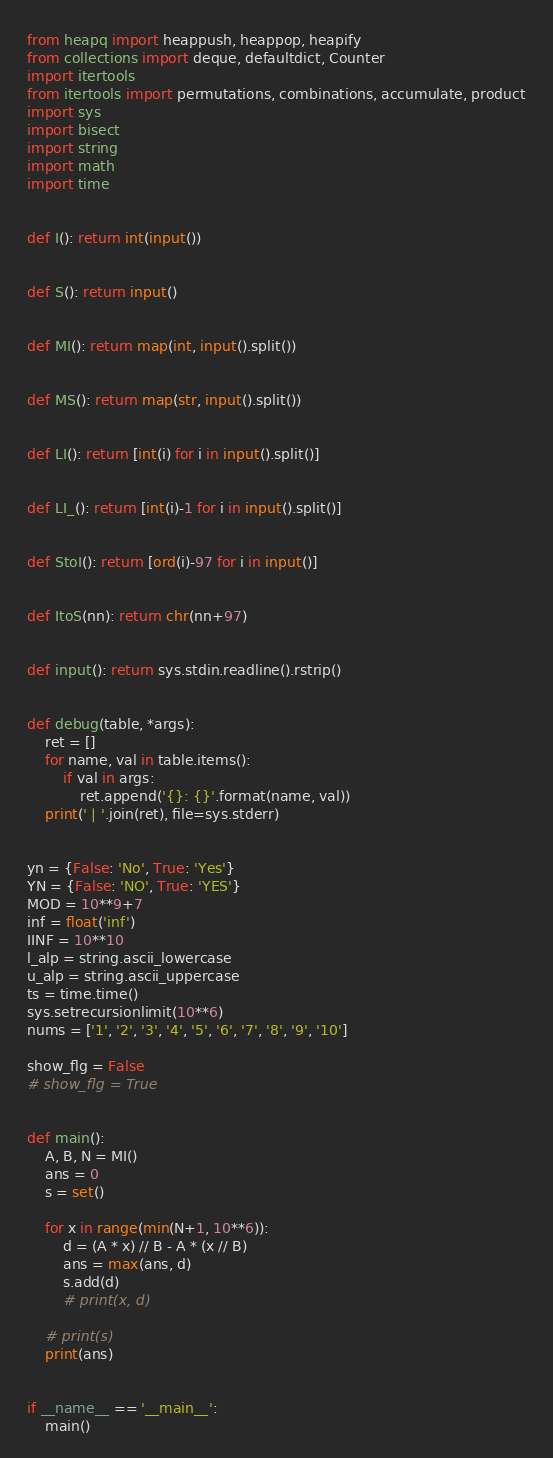<code> <loc_0><loc_0><loc_500><loc_500><_Python_>from heapq import heappush, heappop, heapify
from collections import deque, defaultdict, Counter
import itertools
from itertools import permutations, combinations, accumulate, product
import sys
import bisect
import string
import math
import time


def I(): return int(input())


def S(): return input()


def MI(): return map(int, input().split())


def MS(): return map(str, input().split())


def LI(): return [int(i) for i in input().split()]


def LI_(): return [int(i)-1 for i in input().split()]


def StoI(): return [ord(i)-97 for i in input()]


def ItoS(nn): return chr(nn+97)


def input(): return sys.stdin.readline().rstrip()


def debug(table, *args):
    ret = []
    for name, val in table.items():
        if val in args:
            ret.append('{}: {}'.format(name, val))
    print(' | '.join(ret), file=sys.stderr)


yn = {False: 'No', True: 'Yes'}
YN = {False: 'NO', True: 'YES'}
MOD = 10**9+7
inf = float('inf')
IINF = 10**10
l_alp = string.ascii_lowercase
u_alp = string.ascii_uppercase
ts = time.time()
sys.setrecursionlimit(10**6)
nums = ['1', '2', '3', '4', '5', '6', '7', '8', '9', '10']

show_flg = False
# show_flg = True


def main():
    A, B, N = MI()
    ans = 0
    s = set()

    for x in range(min(N+1, 10**6)):
        d = (A * x) // B - A * (x // B)
        ans = max(ans, d)
        s.add(d)
        # print(x, d)

    # print(s)
    print(ans)


if __name__ == '__main__':
    main()
</code> 